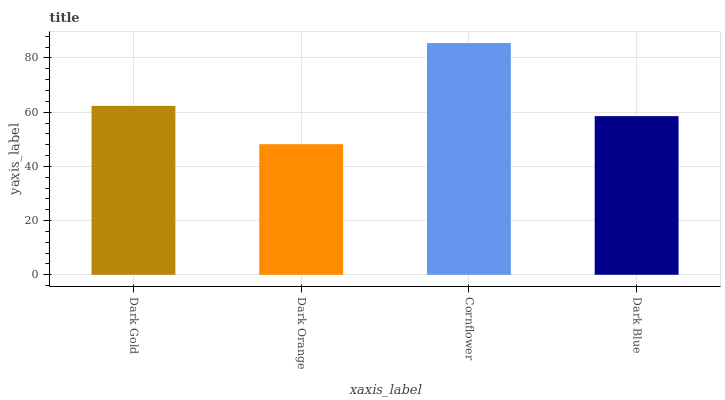Is Dark Orange the minimum?
Answer yes or no. Yes. Is Cornflower the maximum?
Answer yes or no. Yes. Is Cornflower the minimum?
Answer yes or no. No. Is Dark Orange the maximum?
Answer yes or no. No. Is Cornflower greater than Dark Orange?
Answer yes or no. Yes. Is Dark Orange less than Cornflower?
Answer yes or no. Yes. Is Dark Orange greater than Cornflower?
Answer yes or no. No. Is Cornflower less than Dark Orange?
Answer yes or no. No. Is Dark Gold the high median?
Answer yes or no. Yes. Is Dark Blue the low median?
Answer yes or no. Yes. Is Dark Blue the high median?
Answer yes or no. No. Is Cornflower the low median?
Answer yes or no. No. 